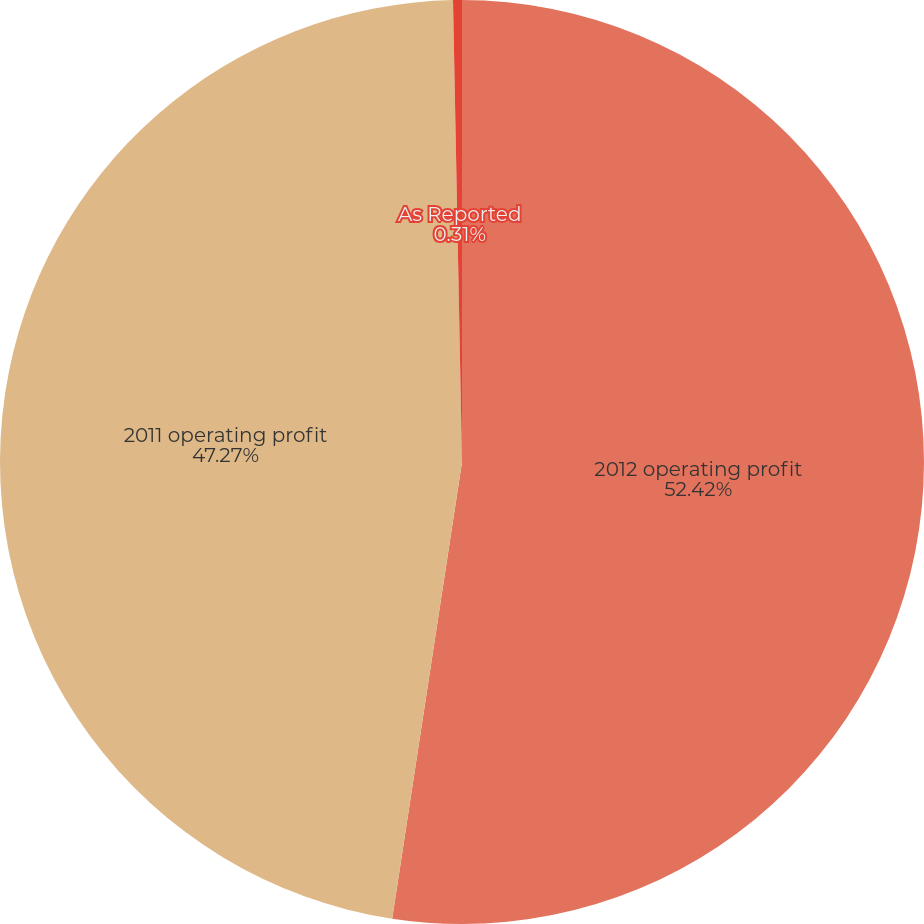Convert chart. <chart><loc_0><loc_0><loc_500><loc_500><pie_chart><fcel>2012 operating profit<fcel>2011 operating profit<fcel>As Reported<nl><fcel>52.41%<fcel>47.27%<fcel>0.31%<nl></chart> 